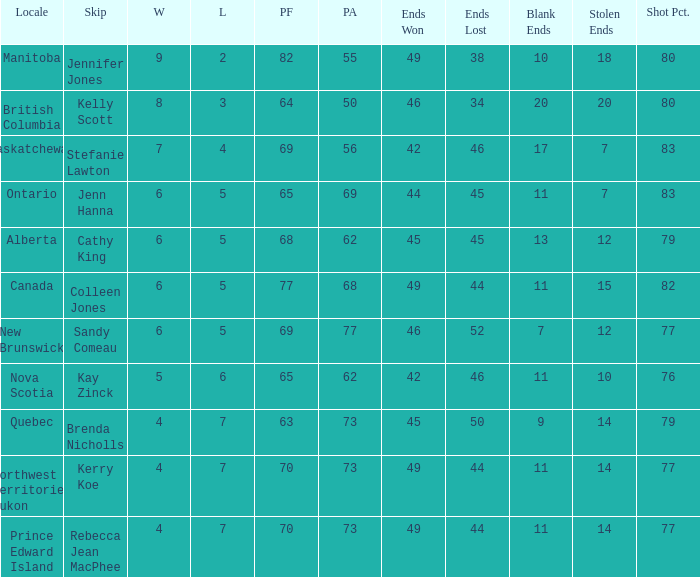What is the pa when the leap is colleen jones? 68.0. 